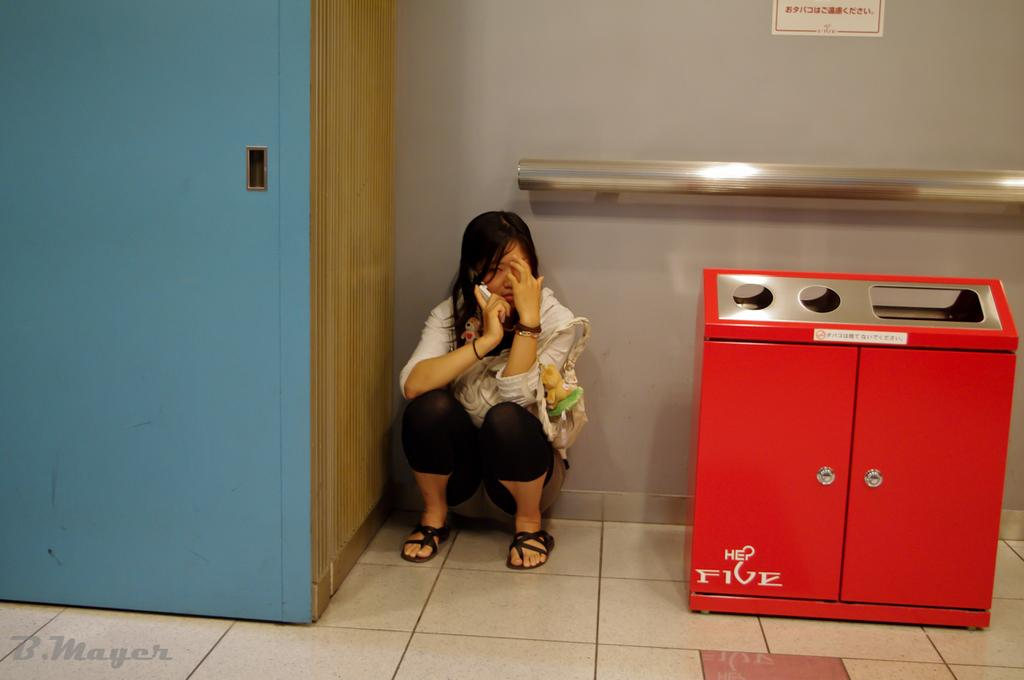Provide a one-sentence caption for the provided image. A woman sits crouched talking on the phone next to a HE Five trash can. 